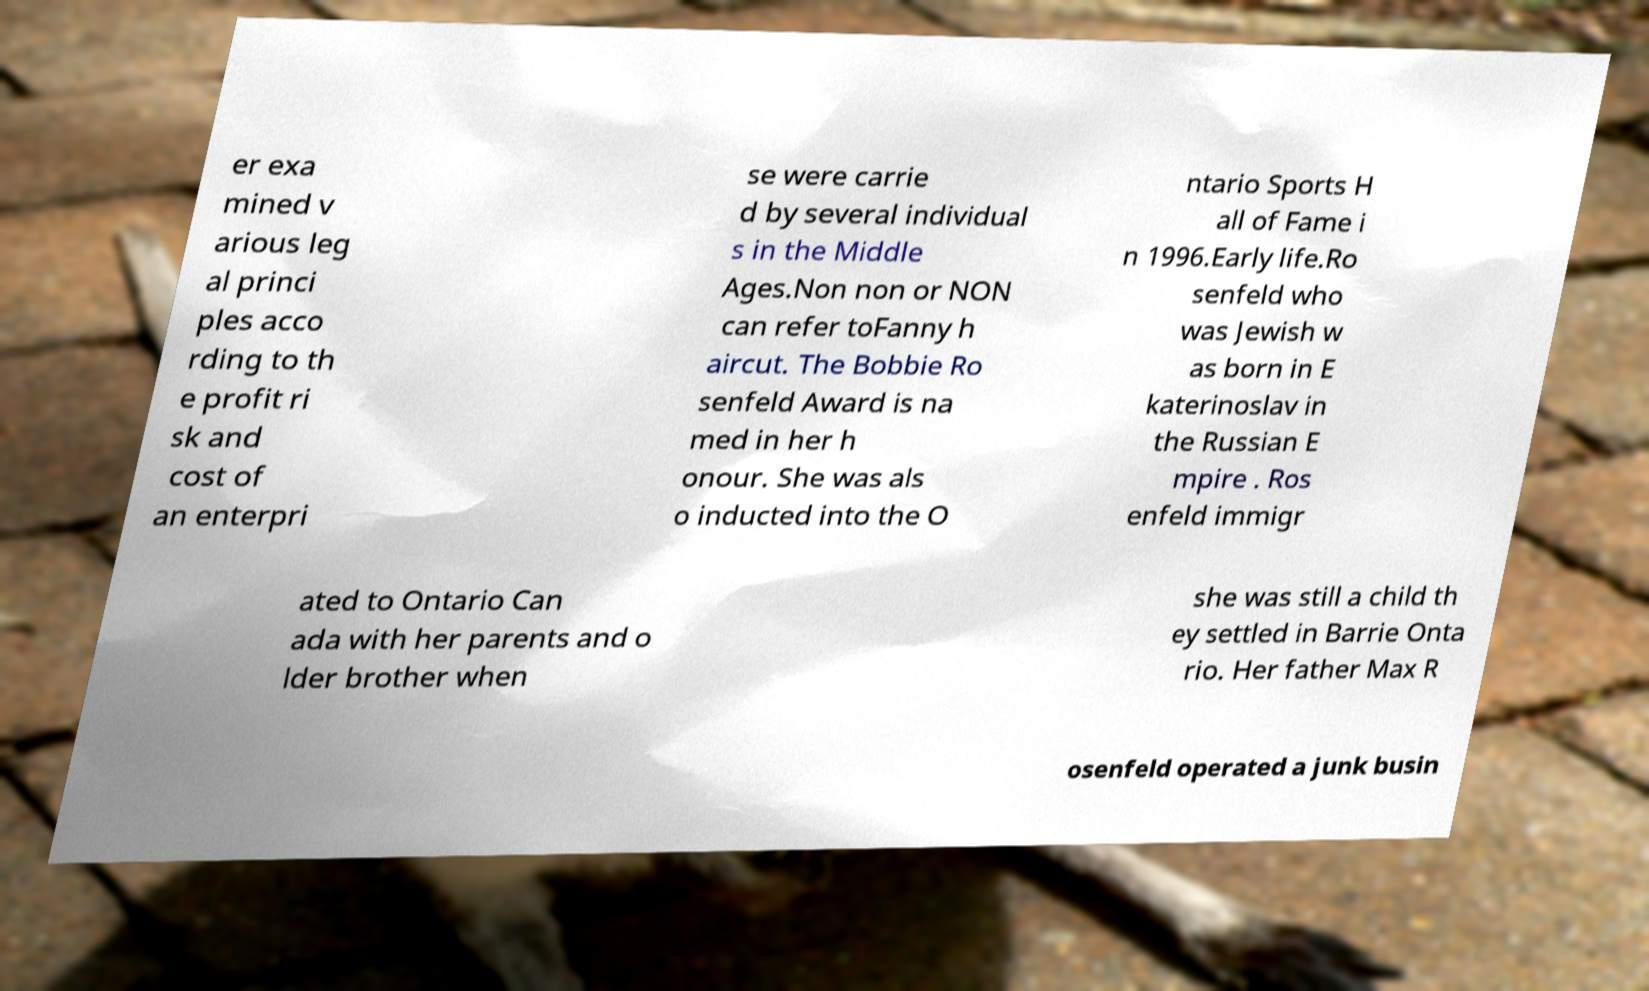There's text embedded in this image that I need extracted. Can you transcribe it verbatim? er exa mined v arious leg al princi ples acco rding to th e profit ri sk and cost of an enterpri se were carrie d by several individual s in the Middle Ages.Non non or NON can refer toFanny h aircut. The Bobbie Ro senfeld Award is na med in her h onour. She was als o inducted into the O ntario Sports H all of Fame i n 1996.Early life.Ro senfeld who was Jewish w as born in E katerinoslav in the Russian E mpire . Ros enfeld immigr ated to Ontario Can ada with her parents and o lder brother when she was still a child th ey settled in Barrie Onta rio. Her father Max R osenfeld operated a junk busin 